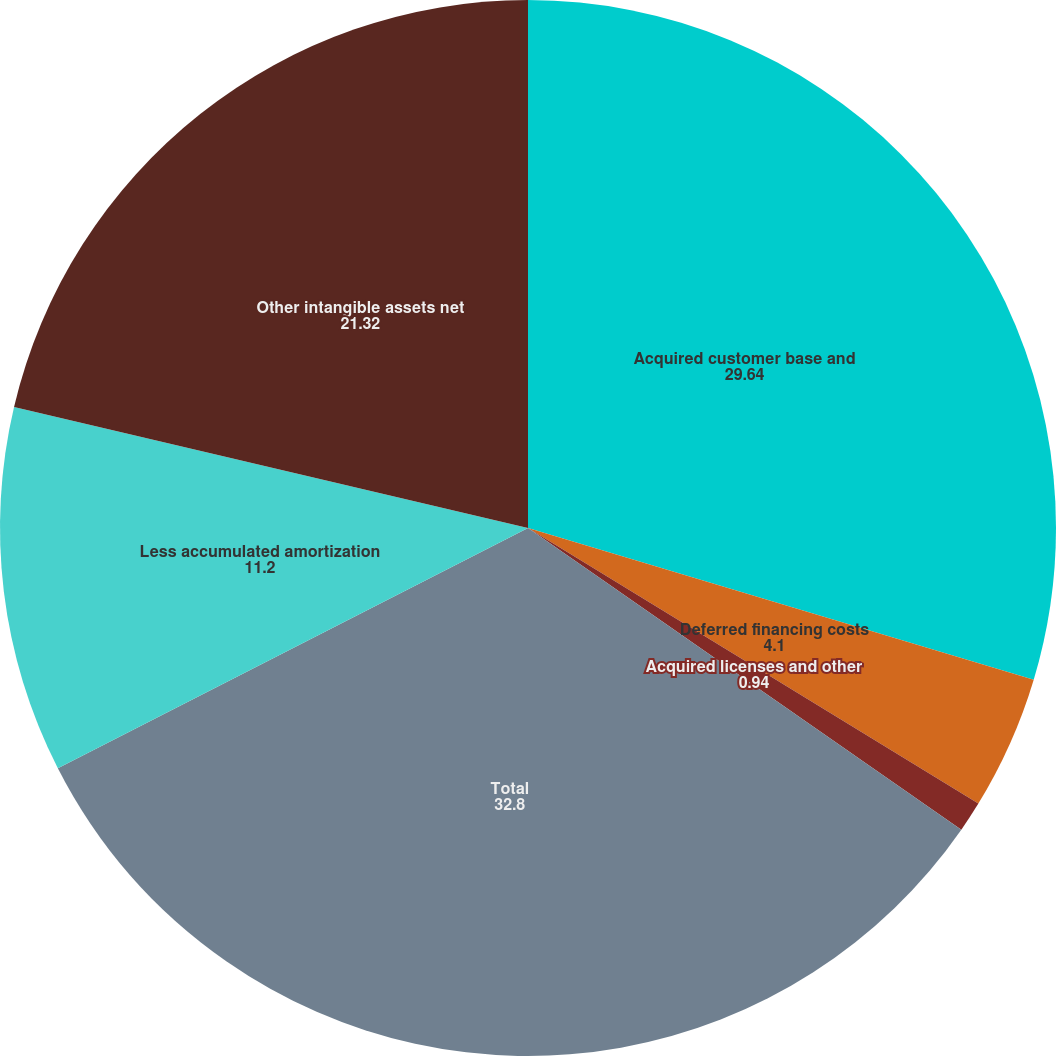Convert chart. <chart><loc_0><loc_0><loc_500><loc_500><pie_chart><fcel>Acquired customer base and<fcel>Deferred financing costs<fcel>Acquired licenses and other<fcel>Total<fcel>Less accumulated amortization<fcel>Other intangible assets net<nl><fcel>29.64%<fcel>4.1%<fcel>0.94%<fcel>32.8%<fcel>11.2%<fcel>21.32%<nl></chart> 